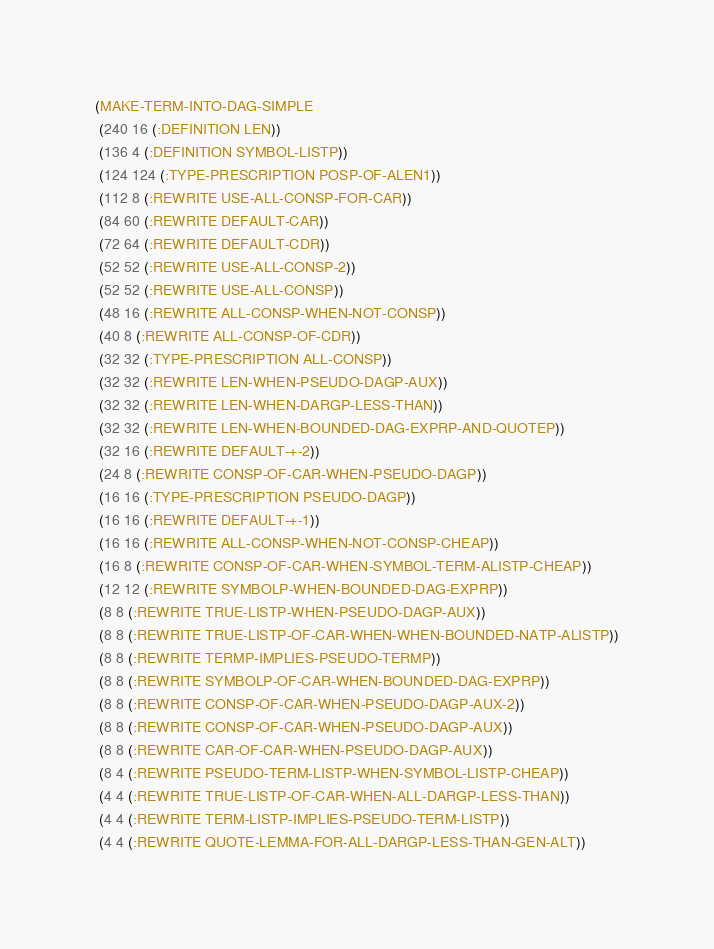Convert code to text. <code><loc_0><loc_0><loc_500><loc_500><_Lisp_>(MAKE-TERM-INTO-DAG-SIMPLE
 (240 16 (:DEFINITION LEN))
 (136 4 (:DEFINITION SYMBOL-LISTP))
 (124 124 (:TYPE-PRESCRIPTION POSP-OF-ALEN1))
 (112 8 (:REWRITE USE-ALL-CONSP-FOR-CAR))
 (84 60 (:REWRITE DEFAULT-CAR))
 (72 64 (:REWRITE DEFAULT-CDR))
 (52 52 (:REWRITE USE-ALL-CONSP-2))
 (52 52 (:REWRITE USE-ALL-CONSP))
 (48 16 (:REWRITE ALL-CONSP-WHEN-NOT-CONSP))
 (40 8 (:REWRITE ALL-CONSP-OF-CDR))
 (32 32 (:TYPE-PRESCRIPTION ALL-CONSP))
 (32 32 (:REWRITE LEN-WHEN-PSEUDO-DAGP-AUX))
 (32 32 (:REWRITE LEN-WHEN-DARGP-LESS-THAN))
 (32 32 (:REWRITE LEN-WHEN-BOUNDED-DAG-EXPRP-AND-QUOTEP))
 (32 16 (:REWRITE DEFAULT-+-2))
 (24 8 (:REWRITE CONSP-OF-CAR-WHEN-PSEUDO-DAGP))
 (16 16 (:TYPE-PRESCRIPTION PSEUDO-DAGP))
 (16 16 (:REWRITE DEFAULT-+-1))
 (16 16 (:REWRITE ALL-CONSP-WHEN-NOT-CONSP-CHEAP))
 (16 8 (:REWRITE CONSP-OF-CAR-WHEN-SYMBOL-TERM-ALISTP-CHEAP))
 (12 12 (:REWRITE SYMBOLP-WHEN-BOUNDED-DAG-EXPRP))
 (8 8 (:REWRITE TRUE-LISTP-WHEN-PSEUDO-DAGP-AUX))
 (8 8 (:REWRITE TRUE-LISTP-OF-CAR-WHEN-WHEN-BOUNDED-NATP-ALISTP))
 (8 8 (:REWRITE TERMP-IMPLIES-PSEUDO-TERMP))
 (8 8 (:REWRITE SYMBOLP-OF-CAR-WHEN-BOUNDED-DAG-EXPRP))
 (8 8 (:REWRITE CONSP-OF-CAR-WHEN-PSEUDO-DAGP-AUX-2))
 (8 8 (:REWRITE CONSP-OF-CAR-WHEN-PSEUDO-DAGP-AUX))
 (8 8 (:REWRITE CAR-OF-CAR-WHEN-PSEUDO-DAGP-AUX))
 (8 4 (:REWRITE PSEUDO-TERM-LISTP-WHEN-SYMBOL-LISTP-CHEAP))
 (4 4 (:REWRITE TRUE-LISTP-OF-CAR-WHEN-ALL-DARGP-LESS-THAN))
 (4 4 (:REWRITE TERM-LISTP-IMPLIES-PSEUDO-TERM-LISTP))
 (4 4 (:REWRITE QUOTE-LEMMA-FOR-ALL-DARGP-LESS-THAN-GEN-ALT))</code> 